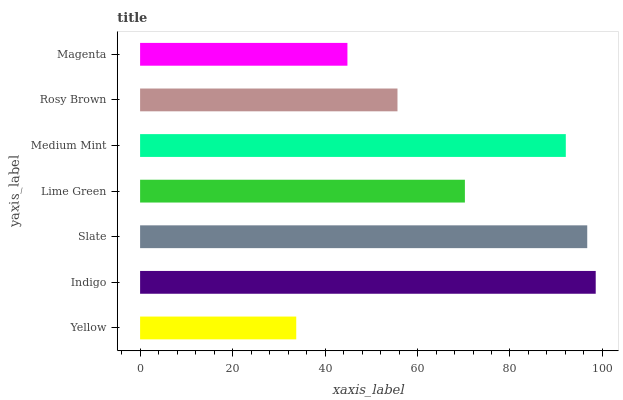Is Yellow the minimum?
Answer yes or no. Yes. Is Indigo the maximum?
Answer yes or no. Yes. Is Slate the minimum?
Answer yes or no. No. Is Slate the maximum?
Answer yes or no. No. Is Indigo greater than Slate?
Answer yes or no. Yes. Is Slate less than Indigo?
Answer yes or no. Yes. Is Slate greater than Indigo?
Answer yes or no. No. Is Indigo less than Slate?
Answer yes or no. No. Is Lime Green the high median?
Answer yes or no. Yes. Is Lime Green the low median?
Answer yes or no. Yes. Is Magenta the high median?
Answer yes or no. No. Is Yellow the low median?
Answer yes or no. No. 